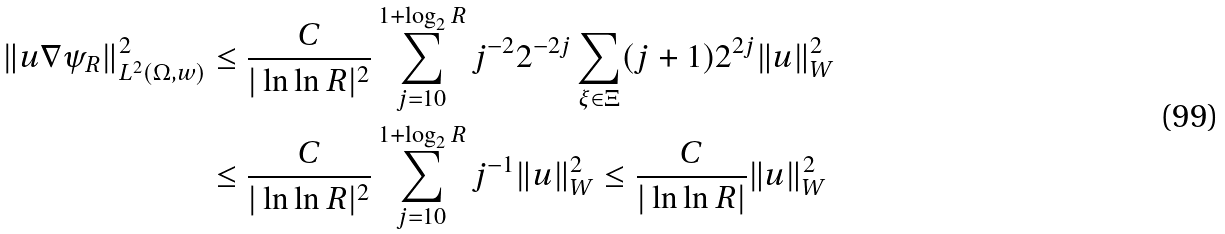Convert formula to latex. <formula><loc_0><loc_0><loc_500><loc_500>\| u \nabla \psi _ { R } \| _ { L ^ { 2 } ( \Omega , w ) } ^ { 2 } & \leq \frac { C } { | \ln \ln R | ^ { 2 } } \sum _ { j = 1 0 } ^ { 1 + \log _ { 2 } R } j ^ { - 2 } 2 ^ { - 2 j } \sum _ { \xi \in \Xi } ( j + 1 ) 2 ^ { 2 j } \| u \| _ { W } ^ { 2 } \\ & \leq \frac { C } { | \ln \ln R | ^ { 2 } } \sum _ { j = 1 0 } ^ { 1 + \log _ { 2 } R } j ^ { - 1 } \| u \| _ { W } ^ { 2 } \leq \frac { C } { | \ln \ln R | } \| u \| _ { W } ^ { 2 }</formula> 